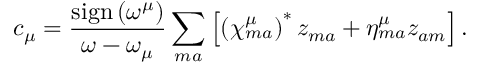<formula> <loc_0><loc_0><loc_500><loc_500>c _ { \mu } = \frac { s i g n \left ( \omega ^ { \mu } \right ) } { \omega - \omega _ { \mu } } \sum _ { m a } \left [ \left ( \chi _ { m a } ^ { \mu } \right ) ^ { * } z _ { m a } + \eta _ { m a } ^ { \mu } z _ { a m } \right ] .</formula> 